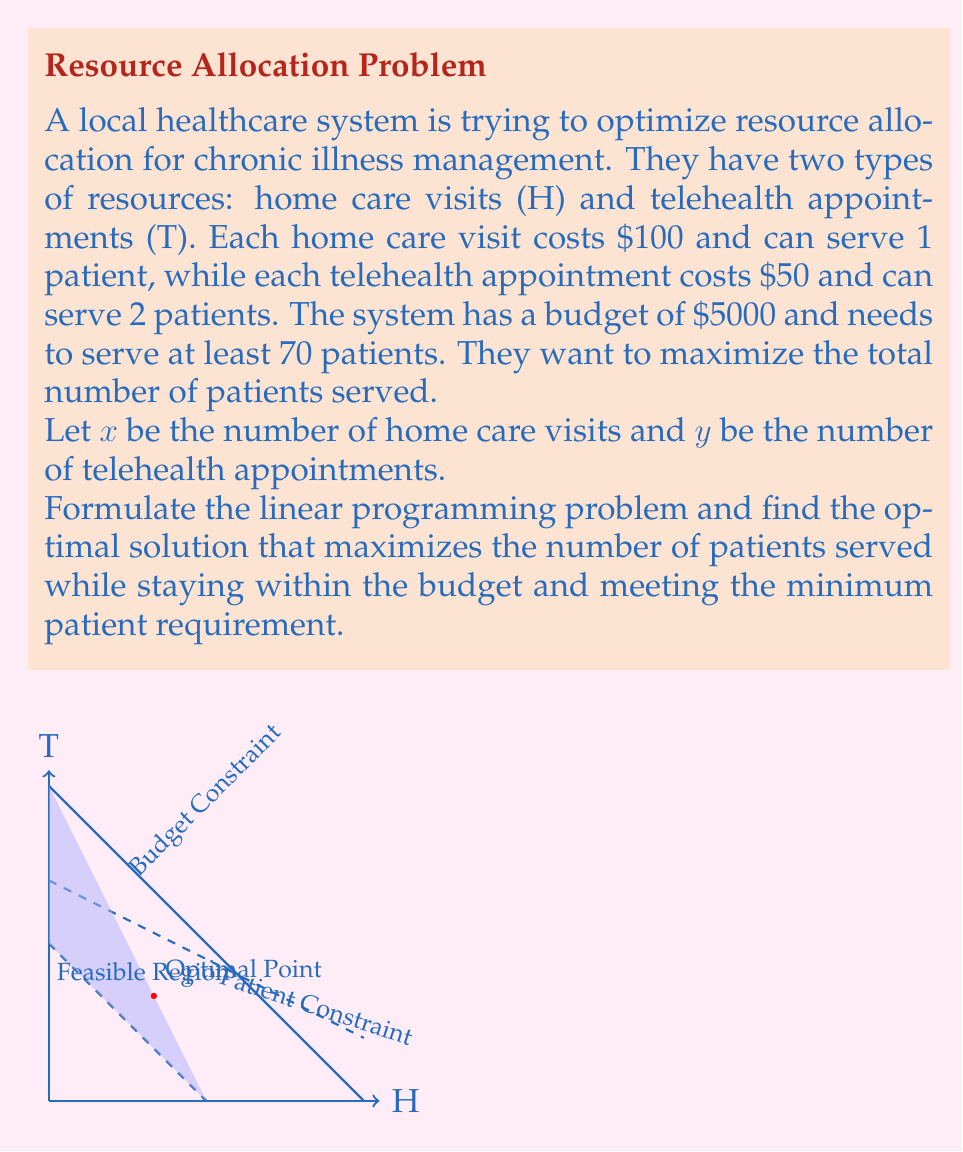What is the answer to this math problem? 1) First, let's formulate the linear programming problem:

   Maximize: $z = x + 2y$ (total patients served)
   Subject to:
   $100x + 50y \leq 5000$ (budget constraint)
   $x + 2y \geq 70$ (minimum patient requirement)
   $x \geq 0, y \geq 0$ (non-negativity constraints)

2) We can solve this graphically or using the simplex method. Let's use the graphical method.

3) Plot the constraints:
   Budget constraint: $100x + 50y = 5000$ or $y = 100 - 2x$
   Patient constraint: $x + 2y = 70$ or $y = 35 - 0.5x$

4) The feasible region is the area that satisfies all constraints.

5) The optimal solution will be at one of the corner points of the feasible region. We need to check these points:

   Point A: (0, 70) - This doesn't satisfy the budget constraint.
   Point B: (0, 50) - Intersection of y-axis and budget constraint.
   Point C: (33.33, 33.33) - Intersection of budget and patient constraints.
   Point D: (70, 0) - Intersection of x-axis and patient constraint.

6) Evaluate the objective function at each feasible point:
   B: z = 0 + 2(50) = 100
   C: z = 33.33 + 2(33.33) = 100
   D: z = 70 + 2(0) = 70

7) The maximum value is 100, achieved at both points B and C. However, point C uses a mix of both resources, which is often preferable in real-world scenarios.

Therefore, the optimal solution is at point C: x = 33.33, y = 33.33.
Answer: 33.33 home care visits and 33.33 telehealth appointments, serving 100 patients. 